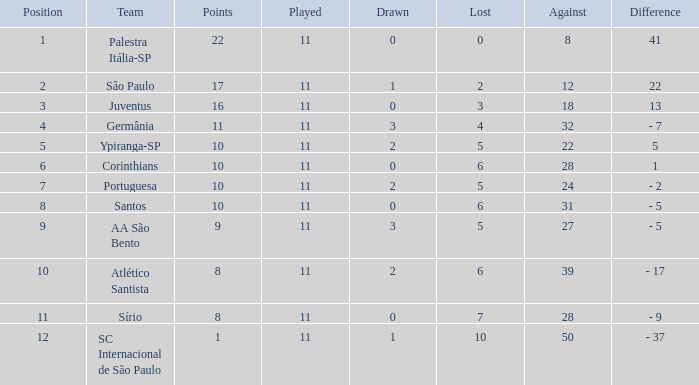What was the total number of Points when the value Difference was 13, and when the value Lost was greater than 3? None. 